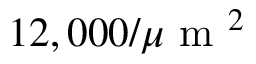<formula> <loc_0><loc_0><loc_500><loc_500>1 2 , 0 0 0 / \mu m ^ { 2 }</formula> 